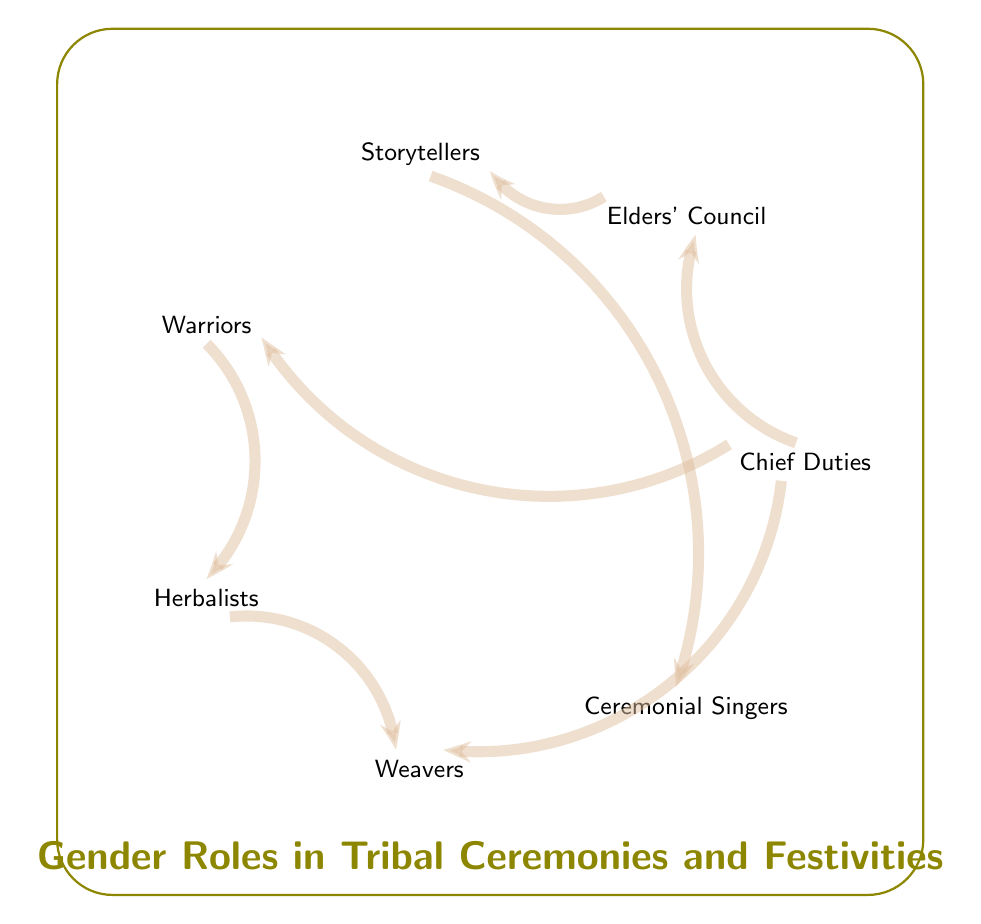What are the nodes in the diagram? The nodes listed in the diagram are: Chief Duties, Elders' Council, Storytellers, Warriors, Herbalists, Weavers, and Ceremonial Singers.
Answer: Chief Duties, Elders' Council, Storytellers, Warriors, Herbalists, Weavers, Ceremonial Singers How many links are in the diagram? Counting all the connections shown between the nodes, there are a total of 7 links.
Answer: 7 Which role is connected to both Warriors and Weavers? The role of Chief Duties is linked to both Warriors and Weavers, indicating its centrality in the diagram.
Answer: Chief Duties What is the relationship between Elders' Council and Storytellers? The Elders' Council is directly linked to the Storytellers, representing a flow of authority and sharing of traditions.
Answer: One connection Who are the direct successors of the Storytellers in the diagram? The direct successor of the Storytellers is the Ceremonial Singers, showing a progression from narratives to performances.
Answer: Ceremonial Singers Which two roles are connected through the Herbalists? The roles connected through the Herbalists are Warriors and Weavers, illustrating collaboration among these roles in ceremonies.
Answer: Warriors, Weavers What is the primary duty linked to the Elders' Council? The primary duty linked to the Elders' Council is the storytelling, which emphasizes the importance of passing down traditions and knowledge.
Answer: Storytellers What does the chord between Warriors and Herbalists indicate? The chord between Warriors and Herbalists suggests a supportive relationship where warriors rely on herbalists for medicinal needs during ceremonies.
Answer: Supportive relationship 